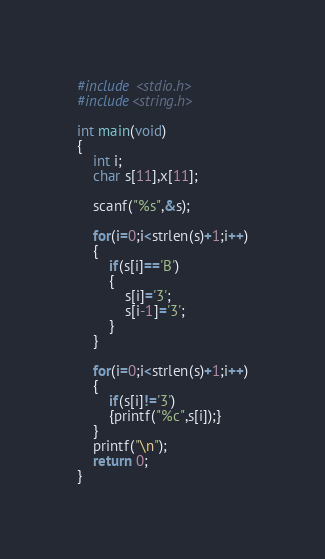<code> <loc_0><loc_0><loc_500><loc_500><_C_>#include <stdio.h>
#include<string.h>

int main(void)
{
	int i;
	char s[11],x[11];
	
	scanf("%s",&s);
	
	for(i=0;i<strlen(s)+1;i++)
	{
		if(s[i]=='B')
		{
			s[i]='3';
			s[i-1]='3';
		}
	}
	
	for(i=0;i<strlen(s)+1;i++)
	{
		if(s[i]!='3')
		{printf("%c",s[i]);}
	}
	printf("\n");
	return 0;	
}</code> 